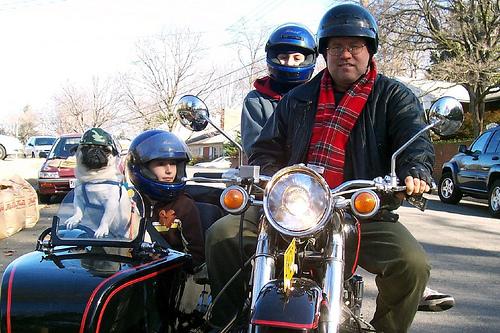What is the pattern on the man's scarf?
Keep it brief. Plaid. Is this in the country?
Answer briefly. No. Is the dog wearing a helmet?
Concise answer only. Yes. 